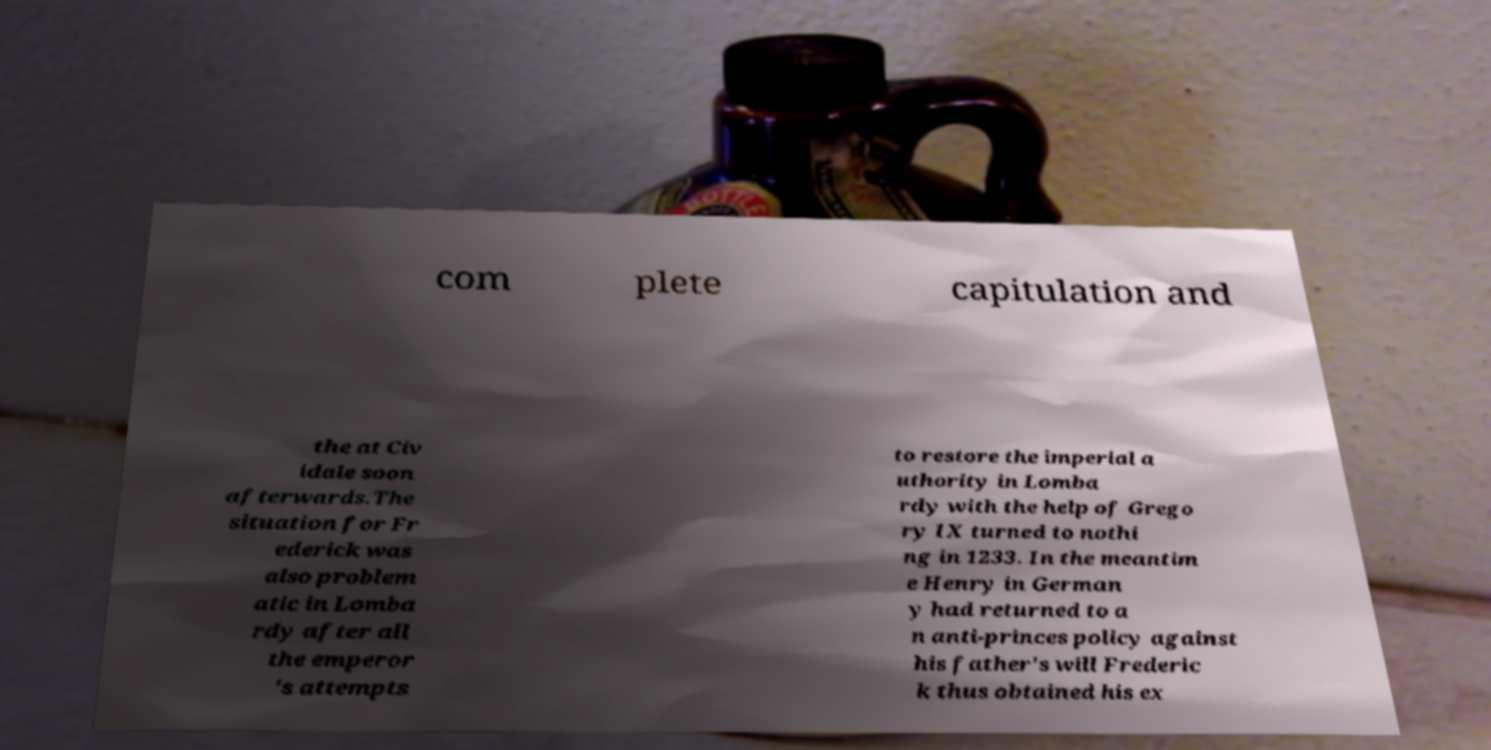Please read and relay the text visible in this image. What does it say? com plete capitulation and the at Civ idale soon afterwards.The situation for Fr ederick was also problem atic in Lomba rdy after all the emperor 's attempts to restore the imperial a uthority in Lomba rdy with the help of Grego ry IX turned to nothi ng in 1233. In the meantim e Henry in German y had returned to a n anti-princes policy against his father's will Frederic k thus obtained his ex 